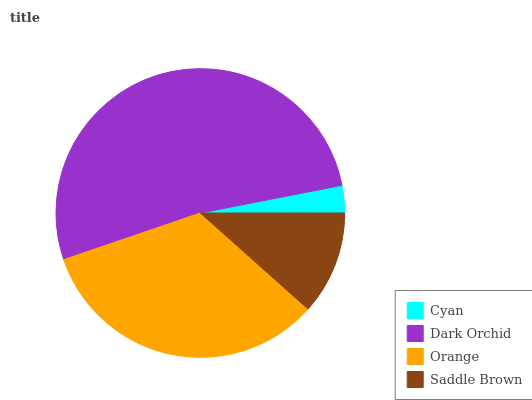Is Cyan the minimum?
Answer yes or no. Yes. Is Dark Orchid the maximum?
Answer yes or no. Yes. Is Orange the minimum?
Answer yes or no. No. Is Orange the maximum?
Answer yes or no. No. Is Dark Orchid greater than Orange?
Answer yes or no. Yes. Is Orange less than Dark Orchid?
Answer yes or no. Yes. Is Orange greater than Dark Orchid?
Answer yes or no. No. Is Dark Orchid less than Orange?
Answer yes or no. No. Is Orange the high median?
Answer yes or no. Yes. Is Saddle Brown the low median?
Answer yes or no. Yes. Is Saddle Brown the high median?
Answer yes or no. No. Is Orange the low median?
Answer yes or no. No. 